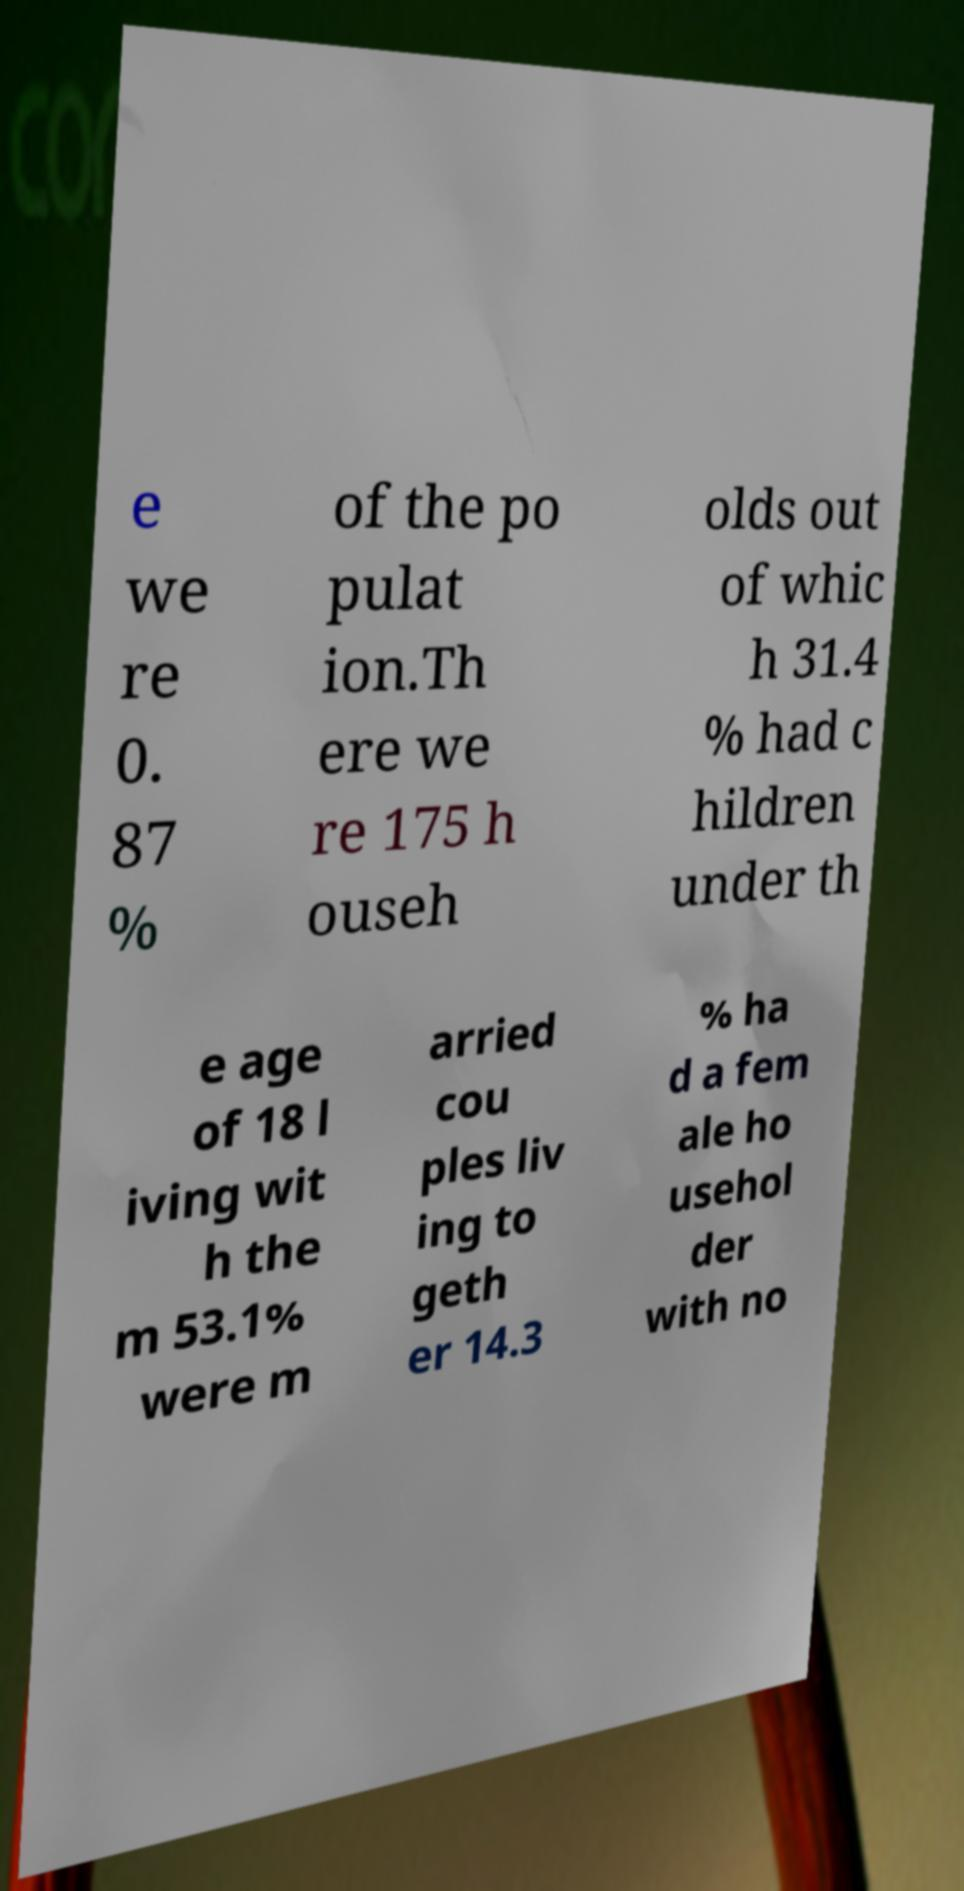Can you read and provide the text displayed in the image?This photo seems to have some interesting text. Can you extract and type it out for me? e we re 0. 87 % of the po pulat ion.Th ere we re 175 h ouseh olds out of whic h 31.4 % had c hildren under th e age of 18 l iving wit h the m 53.1% were m arried cou ples liv ing to geth er 14.3 % ha d a fem ale ho usehol der with no 